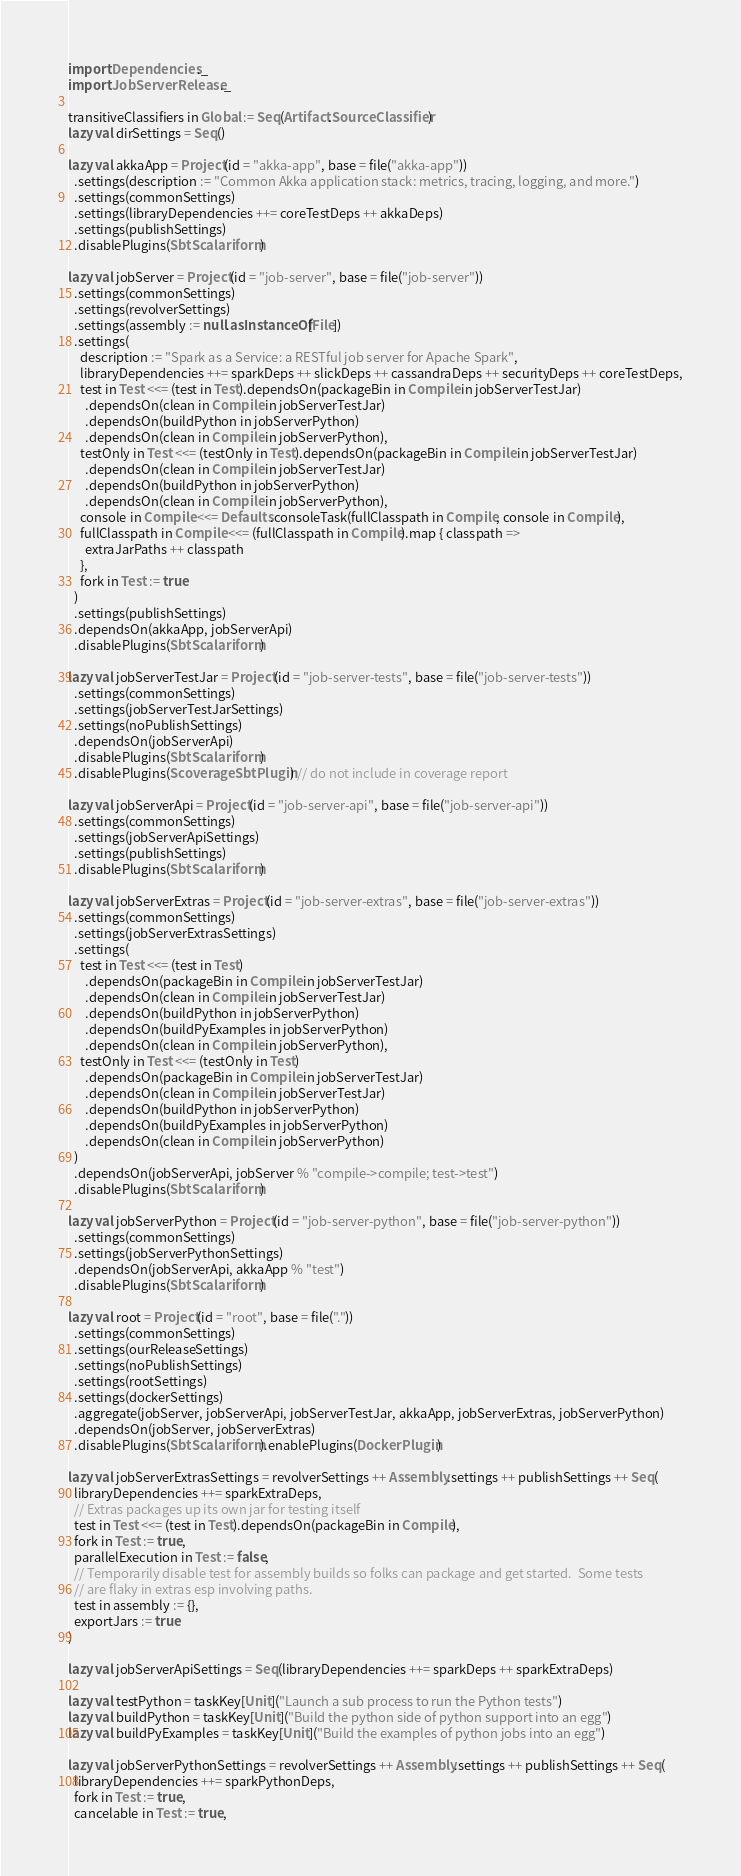<code> <loc_0><loc_0><loc_500><loc_500><_Scala_>
import Dependencies._
import JobServerRelease._

transitiveClassifiers in Global := Seq(Artifact.SourceClassifier)
lazy val dirSettings = Seq()

lazy val akkaApp = Project(id = "akka-app", base = file("akka-app"))
  .settings(description := "Common Akka application stack: metrics, tracing, logging, and more.")
  .settings(commonSettings)
  .settings(libraryDependencies ++= coreTestDeps ++ akkaDeps)
  .settings(publishSettings)
  .disablePlugins(SbtScalariform)

lazy val jobServer = Project(id = "job-server", base = file("job-server"))
  .settings(commonSettings)
  .settings(revolverSettings)
  .settings(assembly := null.asInstanceOf[File])
  .settings(
    description := "Spark as a Service: a RESTful job server for Apache Spark",
    libraryDependencies ++= sparkDeps ++ slickDeps ++ cassandraDeps ++ securityDeps ++ coreTestDeps,
    test in Test <<= (test in Test).dependsOn(packageBin in Compile in jobServerTestJar)
      .dependsOn(clean in Compile in jobServerTestJar)
      .dependsOn(buildPython in jobServerPython)
      .dependsOn(clean in Compile in jobServerPython),
    testOnly in Test <<= (testOnly in Test).dependsOn(packageBin in Compile in jobServerTestJar)
      .dependsOn(clean in Compile in jobServerTestJar)
      .dependsOn(buildPython in jobServerPython)
      .dependsOn(clean in Compile in jobServerPython),
    console in Compile <<= Defaults.consoleTask(fullClasspath in Compile, console in Compile),
    fullClasspath in Compile <<= (fullClasspath in Compile).map { classpath =>
      extraJarPaths ++ classpath
    },
    fork in Test := true
  )
  .settings(publishSettings)
  .dependsOn(akkaApp, jobServerApi)
  .disablePlugins(SbtScalariform)

lazy val jobServerTestJar = Project(id = "job-server-tests", base = file("job-server-tests"))
  .settings(commonSettings)
  .settings(jobServerTestJarSettings)
  .settings(noPublishSettings)
  .dependsOn(jobServerApi)
  .disablePlugins(SbtScalariform)
  .disablePlugins(ScoverageSbtPlugin) // do not include in coverage report

lazy val jobServerApi = Project(id = "job-server-api", base = file("job-server-api"))
  .settings(commonSettings)
  .settings(jobServerApiSettings)
  .settings(publishSettings)
  .disablePlugins(SbtScalariform)

lazy val jobServerExtras = Project(id = "job-server-extras", base = file("job-server-extras"))
  .settings(commonSettings)
  .settings(jobServerExtrasSettings)
  .settings(
    test in Test <<= (test in Test)
      .dependsOn(packageBin in Compile in jobServerTestJar)
      .dependsOn(clean in Compile in jobServerTestJar)
      .dependsOn(buildPython in jobServerPython)
      .dependsOn(buildPyExamples in jobServerPython)
      .dependsOn(clean in Compile in jobServerPython),
    testOnly in Test <<= (testOnly in Test)
      .dependsOn(packageBin in Compile in jobServerTestJar)
      .dependsOn(clean in Compile in jobServerTestJar)
      .dependsOn(buildPython in jobServerPython)
      .dependsOn(buildPyExamples in jobServerPython)
      .dependsOn(clean in Compile in jobServerPython)
  )
  .dependsOn(jobServerApi, jobServer % "compile->compile; test->test")
  .disablePlugins(SbtScalariform)

lazy val jobServerPython = Project(id = "job-server-python", base = file("job-server-python"))
  .settings(commonSettings)
  .settings(jobServerPythonSettings)
  .dependsOn(jobServerApi, akkaApp % "test")
  .disablePlugins(SbtScalariform)

lazy val root = Project(id = "root", base = file("."))
  .settings(commonSettings)
  .settings(ourReleaseSettings)
  .settings(noPublishSettings)
  .settings(rootSettings)
  .settings(dockerSettings)
  .aggregate(jobServer, jobServerApi, jobServerTestJar, akkaApp, jobServerExtras, jobServerPython)
  .dependsOn(jobServer, jobServerExtras)
  .disablePlugins(SbtScalariform).enablePlugins(DockerPlugin)

lazy val jobServerExtrasSettings = revolverSettings ++ Assembly.settings ++ publishSettings ++ Seq(
  libraryDependencies ++= sparkExtraDeps,
  // Extras packages up its own jar for testing itself
  test in Test <<= (test in Test).dependsOn(packageBin in Compile),
  fork in Test := true,
  parallelExecution in Test := false,
  // Temporarily disable test for assembly builds so folks can package and get started.  Some tests
  // are flaky in extras esp involving paths.
  test in assembly := {},
  exportJars := true
)

lazy val jobServerApiSettings = Seq(libraryDependencies ++= sparkDeps ++ sparkExtraDeps)

lazy val testPython = taskKey[Unit]("Launch a sub process to run the Python tests")
lazy val buildPython = taskKey[Unit]("Build the python side of python support into an egg")
lazy val buildPyExamples = taskKey[Unit]("Build the examples of python jobs into an egg")

lazy val jobServerPythonSettings = revolverSettings ++ Assembly.settings ++ publishSettings ++ Seq(
  libraryDependencies ++= sparkPythonDeps,
  fork in Test := true,
  cancelable in Test := true,</code> 